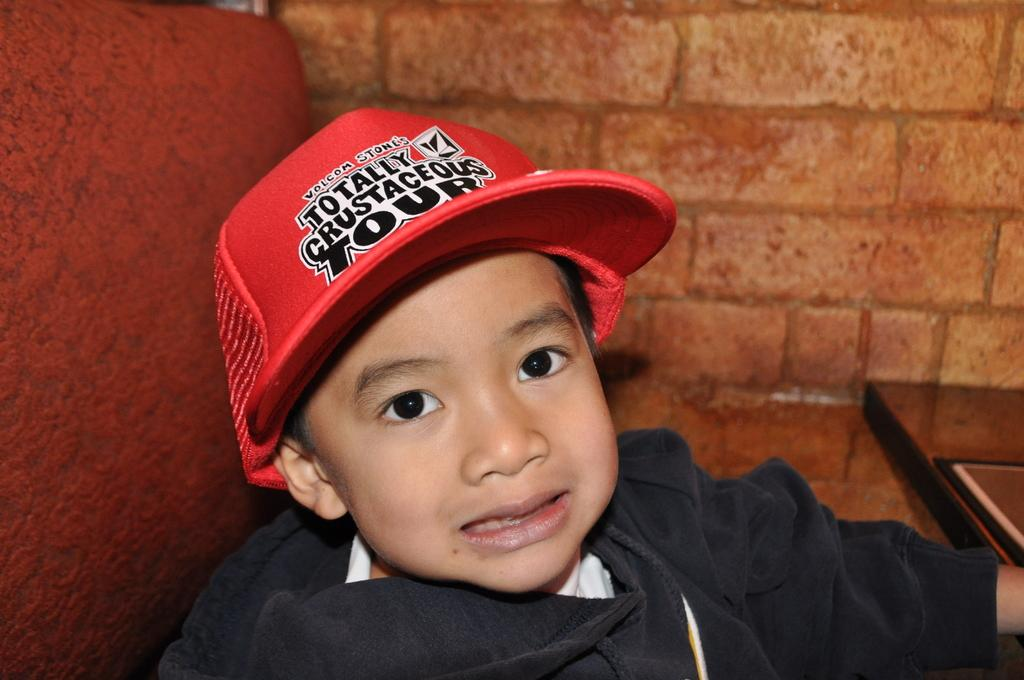Who or what is the main subject of the image? The main subject of the image is a child. What is the child wearing on their head? The child is wearing a red cap. What can be seen in the background of the image? There is a brick wall in the background of the image. Is there any text or design on the child's cap? Yes, there is writing on the child's cap. Can you tell me how many frogs are sitting on the child's shoulder in the image? There are no frogs present in the image, so it is not possible to determine how many might be sitting on the child's shoulder. 